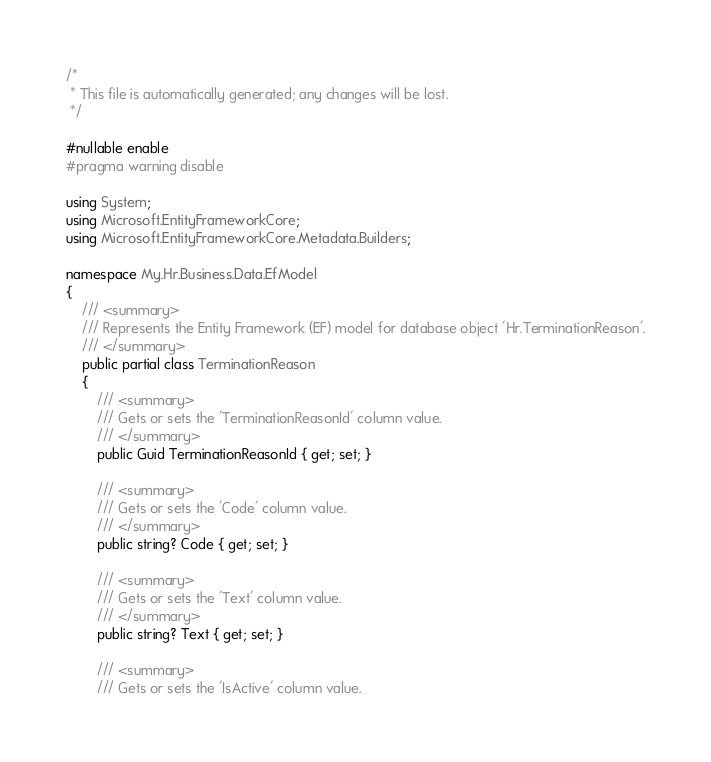<code> <loc_0><loc_0><loc_500><loc_500><_C#_>/*
 * This file is automatically generated; any changes will be lost. 
 */

#nullable enable
#pragma warning disable

using System;
using Microsoft.EntityFrameworkCore;
using Microsoft.EntityFrameworkCore.Metadata.Builders;

namespace My.Hr.Business.Data.EfModel
{
    /// <summary>
    /// Represents the Entity Framework (EF) model for database object 'Hr.TerminationReason'.
    /// </summary>
    public partial class TerminationReason
    {
        /// <summary>
        /// Gets or sets the 'TerminationReasonId' column value.
        /// </summary>
        public Guid TerminationReasonId { get; set; }

        /// <summary>
        /// Gets or sets the 'Code' column value.
        /// </summary>
        public string? Code { get; set; }

        /// <summary>
        /// Gets or sets the 'Text' column value.
        /// </summary>
        public string? Text { get; set; }

        /// <summary>
        /// Gets or sets the 'IsActive' column value.</code> 